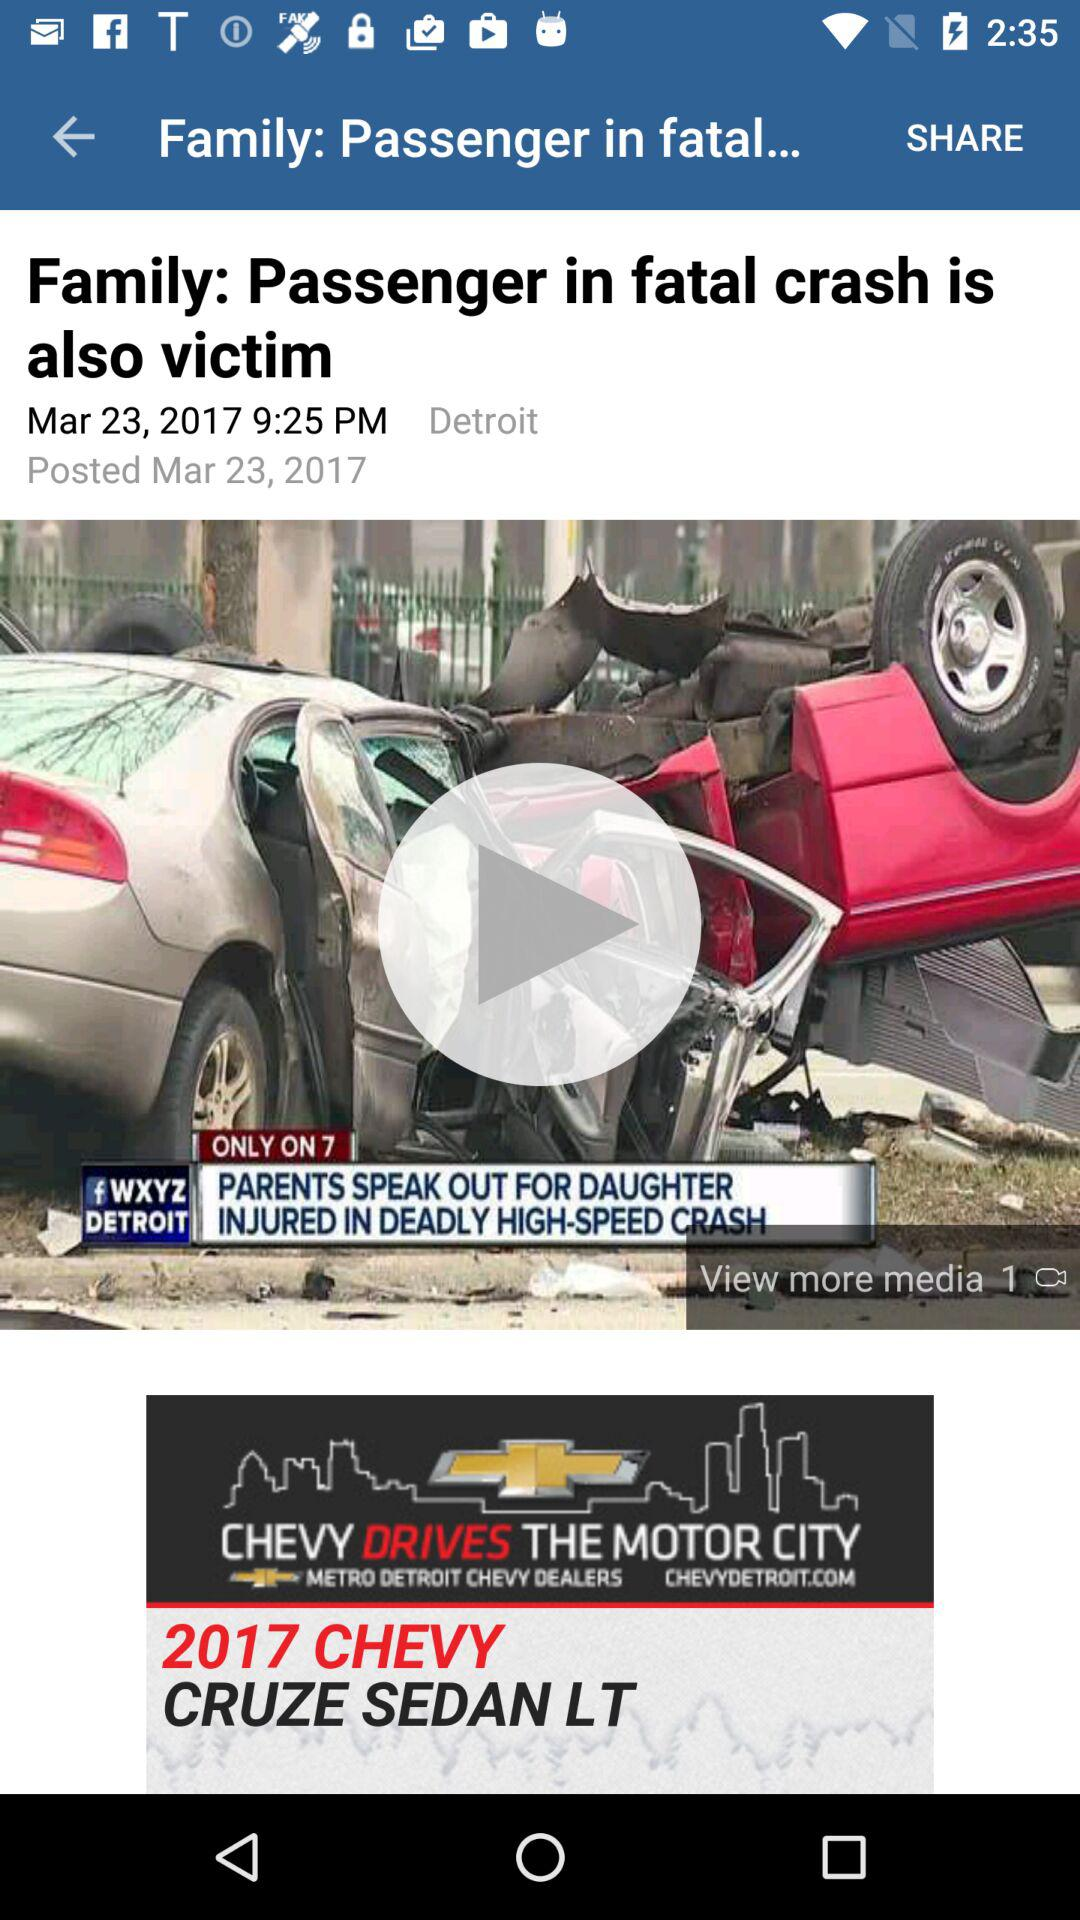What is the shown time? The shown time is 9:25 p.m. 